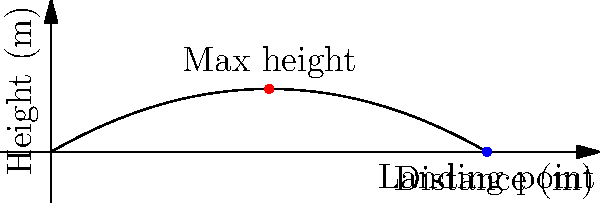In the last SC Telstar match, the goalkeeper made a powerful goal kick with an initial velocity of 25 m/s at an angle of 30 degrees above the horizontal. Assuming no air resistance, what is the maximum height reached by the ball during its flight? To find the maximum height of the ball, we'll follow these steps:

1) First, we need to find the vertical component of the initial velocity:
   $v_{0y} = v_0 \sin(\theta) = 25 \sin(30°) = 12.5$ m/s

2) The time to reach the maximum height is when the vertical velocity becomes zero:
   $v_y = v_{0y} - gt = 0$
   $t = \frac{v_{0y}}{g} = \frac{12.5}{9.8} = 1.276$ seconds

3) Now we can use the equation for displacement to find the maximum height:
   $y = v_{0y}t - \frac{1}{2}gt^2$
   
   Substituting our values:
   $y = 12.5 \times 1.276 - \frac{1}{2} \times 9.8 \times 1.276^2$
   $y = 15.95 - 8.0 = 7.95$ meters

Therefore, the maximum height reached by the ball is approximately 7.95 meters.
Answer: 7.95 meters 